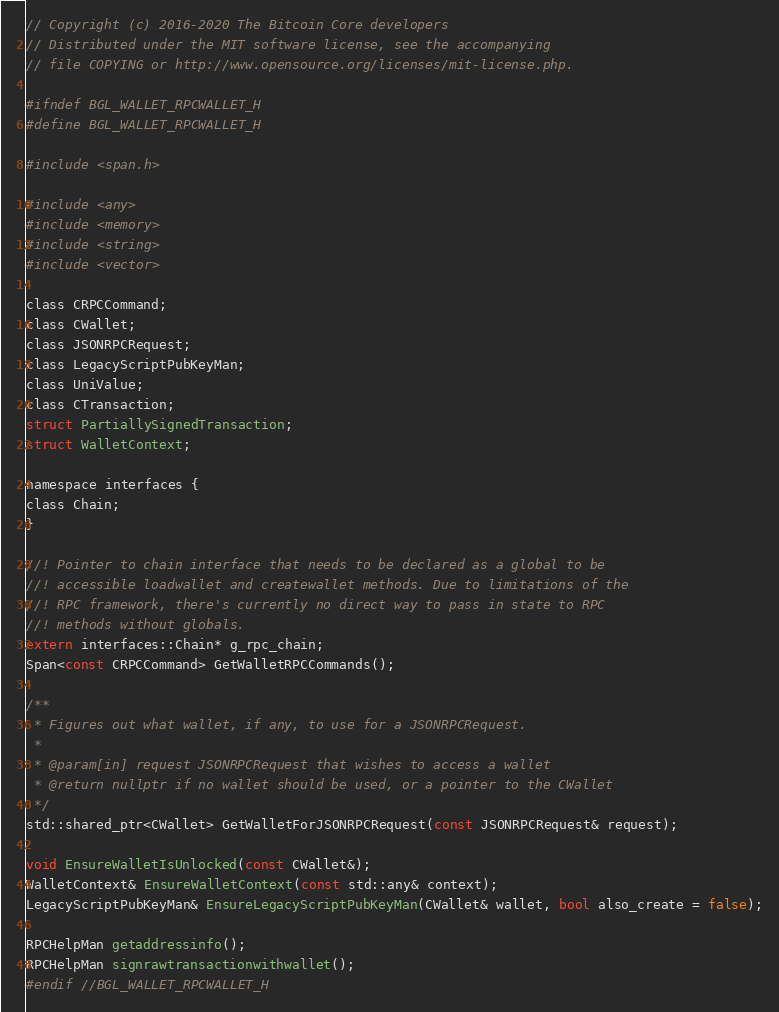Convert code to text. <code><loc_0><loc_0><loc_500><loc_500><_C_>// Copyright (c) 2016-2020 The Bitcoin Core developers
// Distributed under the MIT software license, see the accompanying
// file COPYING or http://www.opensource.org/licenses/mit-license.php.

#ifndef BGL_WALLET_RPCWALLET_H
#define BGL_WALLET_RPCWALLET_H

#include <span.h>

#include <any>
#include <memory>
#include <string>
#include <vector>

class CRPCCommand;
class CWallet;
class JSONRPCRequest;
class LegacyScriptPubKeyMan;
class UniValue;
class CTransaction;
struct PartiallySignedTransaction;
struct WalletContext;

namespace interfaces {
class Chain;
}

//! Pointer to chain interface that needs to be declared as a global to be
//! accessible loadwallet and createwallet methods. Due to limitations of the
//! RPC framework, there's currently no direct way to pass in state to RPC
//! methods without globals.
extern interfaces::Chain* g_rpc_chain;
Span<const CRPCCommand> GetWalletRPCCommands();

/**
 * Figures out what wallet, if any, to use for a JSONRPCRequest.
 *
 * @param[in] request JSONRPCRequest that wishes to access a wallet
 * @return nullptr if no wallet should be used, or a pointer to the CWallet
 */
std::shared_ptr<CWallet> GetWalletForJSONRPCRequest(const JSONRPCRequest& request);

void EnsureWalletIsUnlocked(const CWallet&);
WalletContext& EnsureWalletContext(const std::any& context);
LegacyScriptPubKeyMan& EnsureLegacyScriptPubKeyMan(CWallet& wallet, bool also_create = false);

RPCHelpMan getaddressinfo();
RPCHelpMan signrawtransactionwithwallet();
#endif //BGL_WALLET_RPCWALLET_H
</code> 